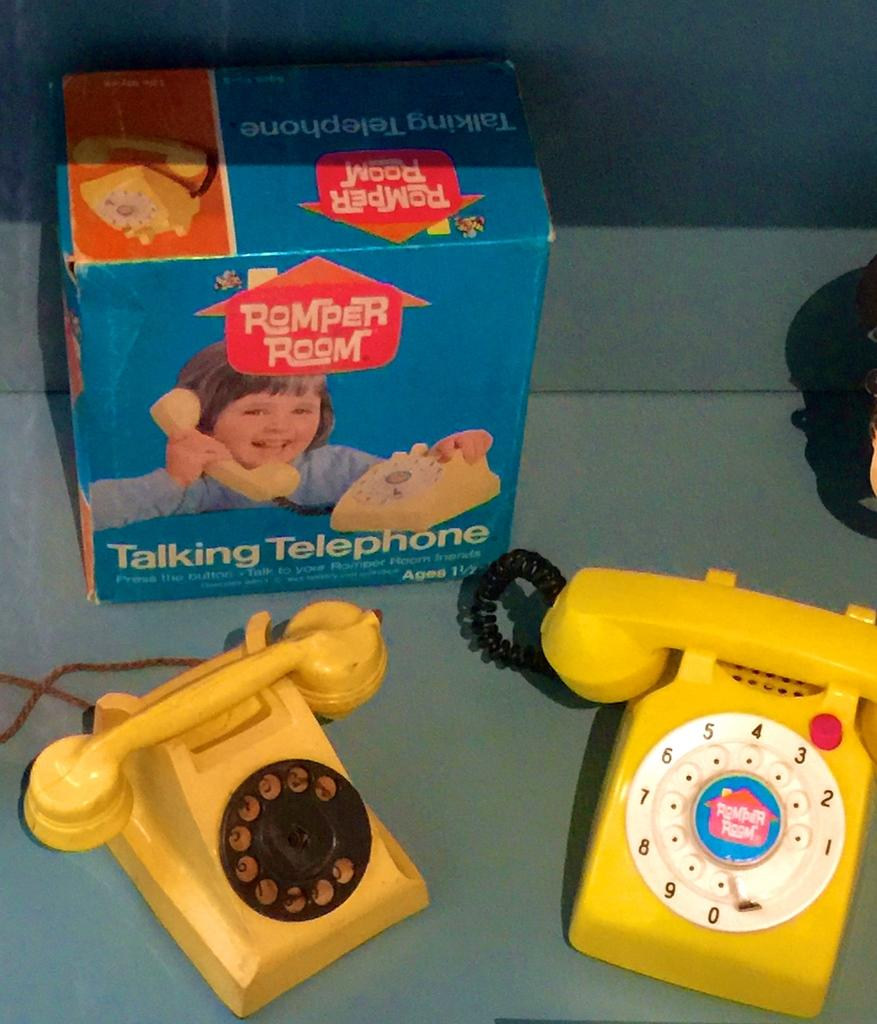<image>
Present a compact description of the photo's key features. A pair of toy telephones including a romper room talking telephone. 